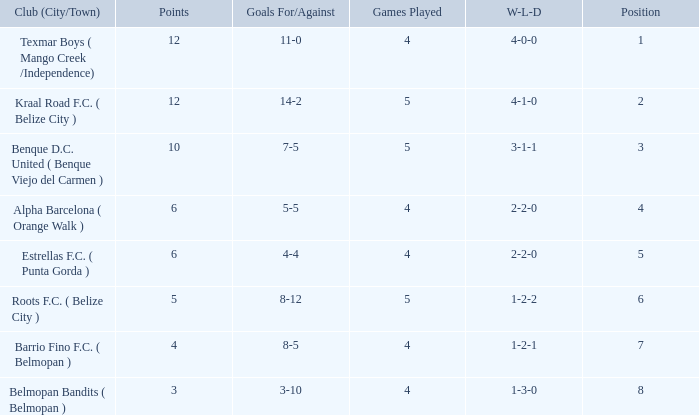Who is the the club (city/town) with goals for/against being 14-2 Kraal Road F.C. ( Belize City ). 